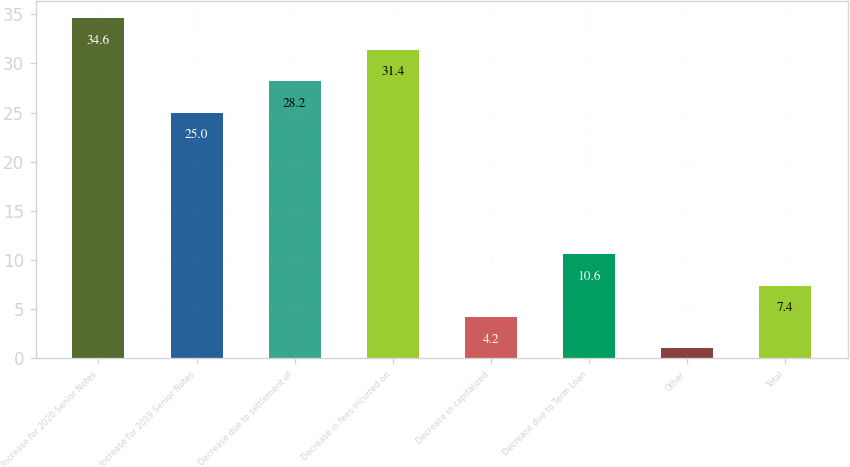Convert chart. <chart><loc_0><loc_0><loc_500><loc_500><bar_chart><fcel>Increase for 2020 Senior Notes<fcel>Increase for 2019 Senior Notes<fcel>Decrease due to settlement of<fcel>Decrease in fees incurred on<fcel>Decrease in capitalized<fcel>Decrease due to Term Loan<fcel>Other<fcel>Total<nl><fcel>34.6<fcel>25<fcel>28.2<fcel>31.4<fcel>4.2<fcel>10.6<fcel>1<fcel>7.4<nl></chart> 